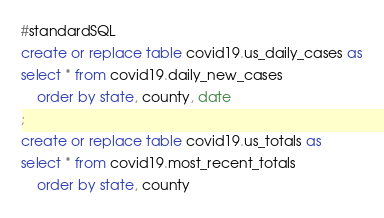<code> <loc_0><loc_0><loc_500><loc_500><_SQL_>#standardSQL
create or replace table covid19.us_daily_cases as
select * from covid19.daily_new_cases
	order by state, county, date
;
create or replace table covid19.us_totals as
select * from covid19.most_recent_totals
	order by state, county
</code> 